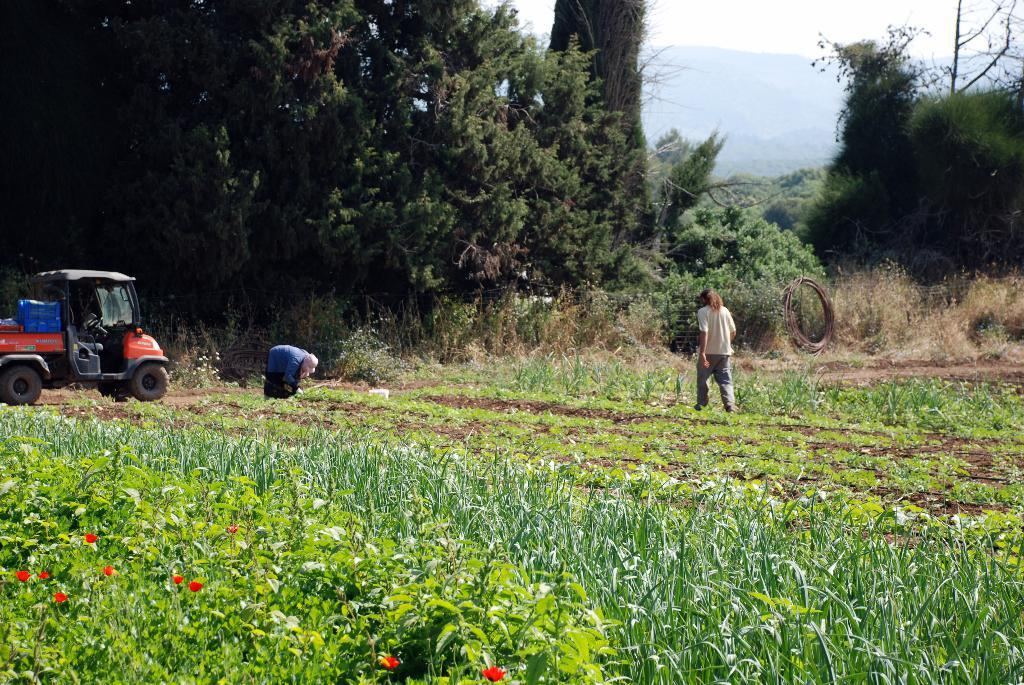How many people are in the image? There are two persons in the image. What else can be seen in the image besides the people? There is a vehicle, a field, flowers, trees, plants, and the sky visible in the image. Can you describe the field in the image? The field has flowers in it. What is visible in the background of the image? Trees, plants, and the sky are visible in the background of the image. What type of ray is being used by the person in the image? There is no ray present in the image. Is there a rifle visible in the image? No, there is no rifle present in the image. 